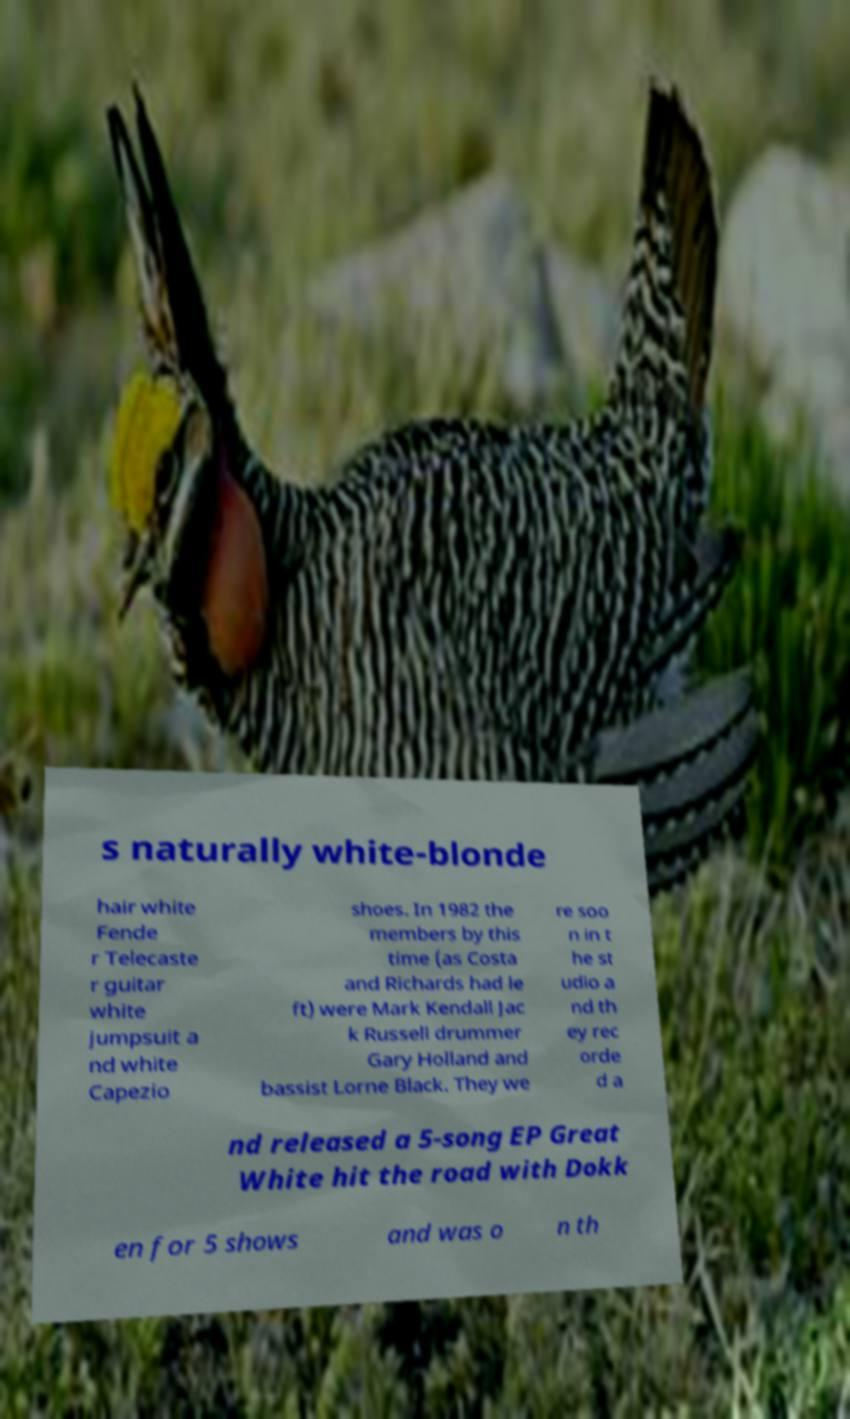Please read and relay the text visible in this image. What does it say? s naturally white-blonde hair white Fende r Telecaste r guitar white jumpsuit a nd white Capezio shoes. In 1982 the members by this time (as Costa and Richards had le ft) were Mark Kendall Jac k Russell drummer Gary Holland and bassist Lorne Black. They we re soo n in t he st udio a nd th ey rec orde d a nd released a 5-song EP Great White hit the road with Dokk en for 5 shows and was o n th 